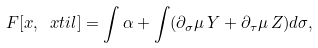Convert formula to latex. <formula><loc_0><loc_0><loc_500><loc_500>F [ x , \ x t i l ] = \int \alpha + \int ( \partial _ { \sigma } \mu \, Y + \partial _ { \tau } \mu \, Z ) d \sigma ,</formula> 